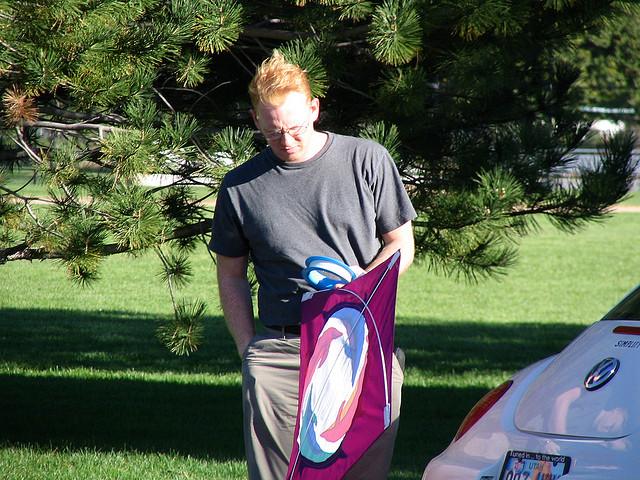Does the tree behind the man produce flowers, or does it produce cones?
Be succinct. Cones. What color kite is the man holding?
Quick response, please. Purple. What color is the kite?
Quick response, please. Purple. 